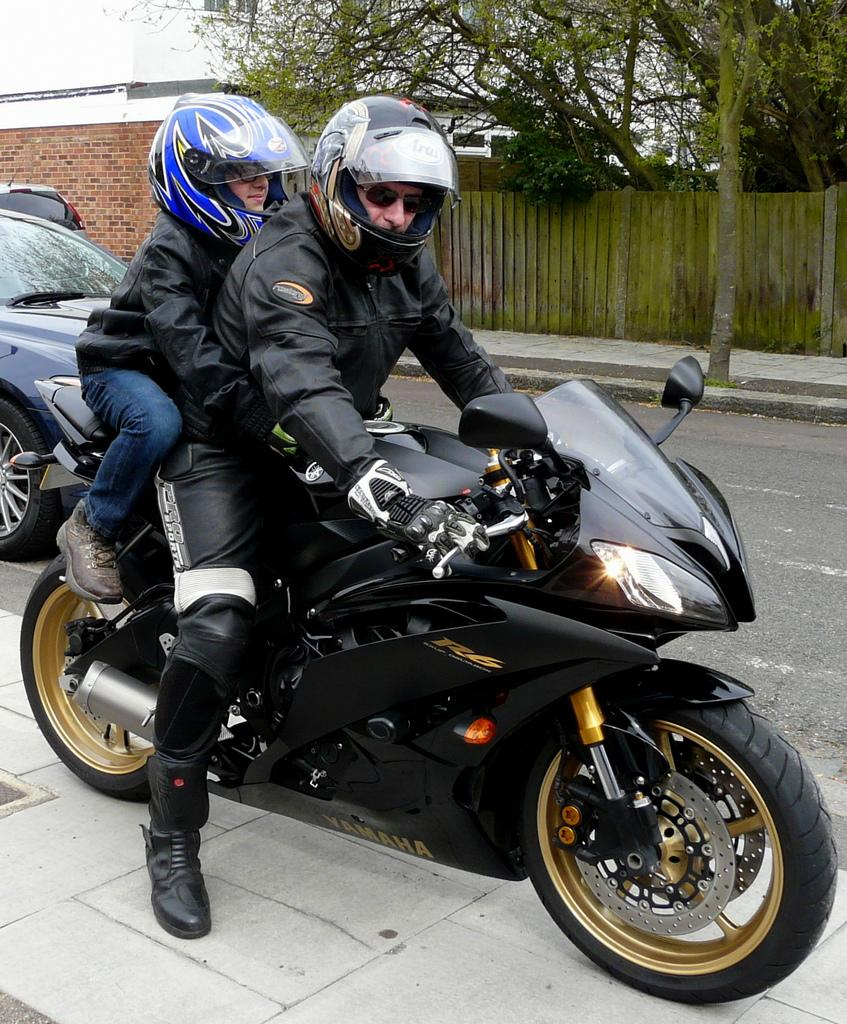How many people are on the bike in the image? There are 2 persons on the bike in the image. Where is the bike located? The bike is on the road in the image. What can be seen in the background of the image? There are vehicles, buildings, trees, and a fence in the background of the image. What type of hole can be seen in the image? There is no hole present in the image. What is the condition of the fence in the image? The provided facts do not mention the condition of the fence, only its presence in the background. 